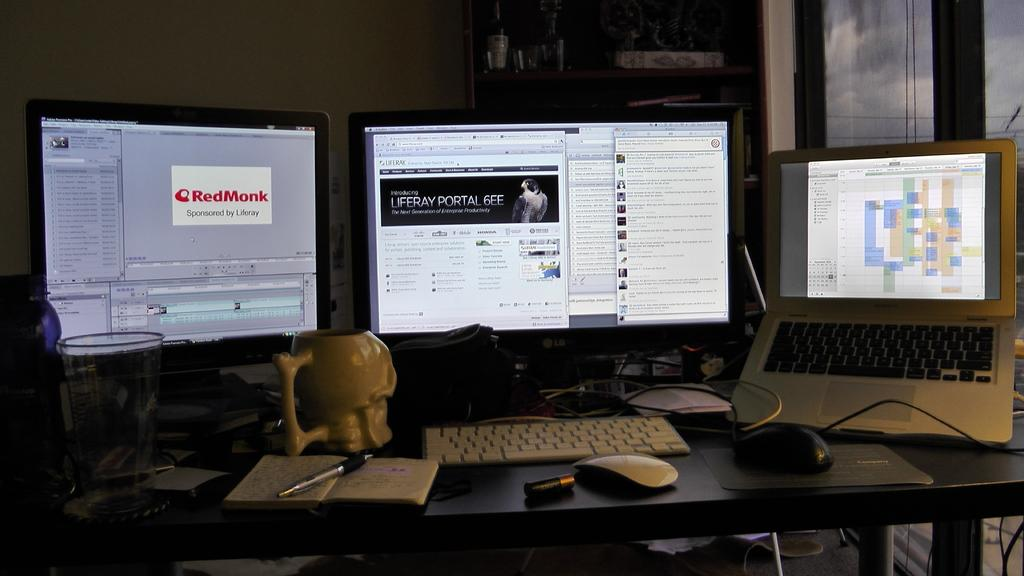Provide a one-sentence caption for the provided image. A desk with 2 monitors one opening up a RedMonk webpage and a laptop. 